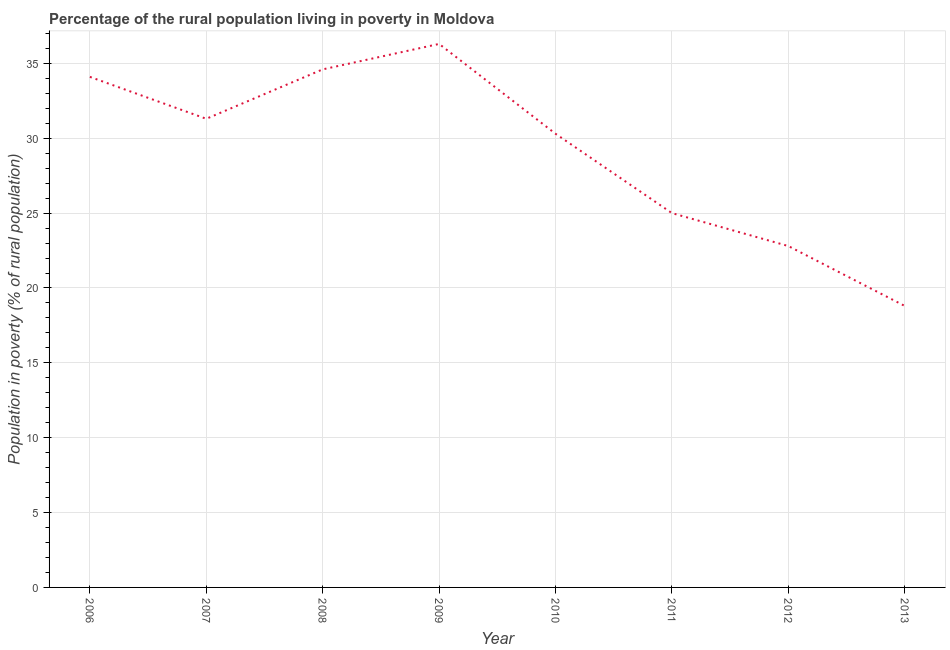Across all years, what is the maximum percentage of rural population living below poverty line?
Ensure brevity in your answer.  36.3. Across all years, what is the minimum percentage of rural population living below poverty line?
Offer a terse response. 18.8. In which year was the percentage of rural population living below poverty line minimum?
Offer a terse response. 2013. What is the sum of the percentage of rural population living below poverty line?
Your answer should be compact. 233.2. What is the difference between the percentage of rural population living below poverty line in 2008 and 2010?
Your answer should be compact. 4.3. What is the average percentage of rural population living below poverty line per year?
Make the answer very short. 29.15. What is the median percentage of rural population living below poverty line?
Make the answer very short. 30.8. What is the ratio of the percentage of rural population living below poverty line in 2012 to that in 2013?
Provide a succinct answer. 1.21. Is the difference between the percentage of rural population living below poverty line in 2010 and 2012 greater than the difference between any two years?
Give a very brief answer. No. What is the difference between the highest and the second highest percentage of rural population living below poverty line?
Your answer should be compact. 1.7. Is the sum of the percentage of rural population living below poverty line in 2006 and 2011 greater than the maximum percentage of rural population living below poverty line across all years?
Provide a short and direct response. Yes. What is the difference between the highest and the lowest percentage of rural population living below poverty line?
Your answer should be very brief. 17.5. In how many years, is the percentage of rural population living below poverty line greater than the average percentage of rural population living below poverty line taken over all years?
Ensure brevity in your answer.  5. Does the percentage of rural population living below poverty line monotonically increase over the years?
Your answer should be compact. No. What is the difference between two consecutive major ticks on the Y-axis?
Keep it short and to the point. 5. Are the values on the major ticks of Y-axis written in scientific E-notation?
Make the answer very short. No. Does the graph contain grids?
Provide a short and direct response. Yes. What is the title of the graph?
Your answer should be compact. Percentage of the rural population living in poverty in Moldova. What is the label or title of the Y-axis?
Offer a very short reply. Population in poverty (% of rural population). What is the Population in poverty (% of rural population) of 2006?
Provide a succinct answer. 34.1. What is the Population in poverty (% of rural population) in 2007?
Your answer should be very brief. 31.3. What is the Population in poverty (% of rural population) of 2008?
Your answer should be very brief. 34.6. What is the Population in poverty (% of rural population) of 2009?
Your answer should be very brief. 36.3. What is the Population in poverty (% of rural population) of 2010?
Make the answer very short. 30.3. What is the Population in poverty (% of rural population) in 2011?
Provide a short and direct response. 25. What is the Population in poverty (% of rural population) of 2012?
Offer a terse response. 22.8. What is the Population in poverty (% of rural population) in 2013?
Ensure brevity in your answer.  18.8. What is the difference between the Population in poverty (% of rural population) in 2006 and 2007?
Offer a terse response. 2.8. What is the difference between the Population in poverty (% of rural population) in 2006 and 2008?
Offer a very short reply. -0.5. What is the difference between the Population in poverty (% of rural population) in 2006 and 2010?
Ensure brevity in your answer.  3.8. What is the difference between the Population in poverty (% of rural population) in 2006 and 2012?
Give a very brief answer. 11.3. What is the difference between the Population in poverty (% of rural population) in 2007 and 2008?
Make the answer very short. -3.3. What is the difference between the Population in poverty (% of rural population) in 2007 and 2011?
Keep it short and to the point. 6.3. What is the difference between the Population in poverty (% of rural population) in 2008 and 2010?
Your answer should be very brief. 4.3. What is the difference between the Population in poverty (% of rural population) in 2008 and 2011?
Offer a terse response. 9.6. What is the difference between the Population in poverty (% of rural population) in 2009 and 2013?
Your response must be concise. 17.5. What is the difference between the Population in poverty (% of rural population) in 2010 and 2011?
Provide a succinct answer. 5.3. What is the difference between the Population in poverty (% of rural population) in 2010 and 2013?
Your response must be concise. 11.5. What is the ratio of the Population in poverty (% of rural population) in 2006 to that in 2007?
Ensure brevity in your answer.  1.09. What is the ratio of the Population in poverty (% of rural population) in 2006 to that in 2008?
Offer a terse response. 0.99. What is the ratio of the Population in poverty (% of rural population) in 2006 to that in 2009?
Give a very brief answer. 0.94. What is the ratio of the Population in poverty (% of rural population) in 2006 to that in 2011?
Offer a very short reply. 1.36. What is the ratio of the Population in poverty (% of rural population) in 2006 to that in 2012?
Your response must be concise. 1.5. What is the ratio of the Population in poverty (% of rural population) in 2006 to that in 2013?
Provide a succinct answer. 1.81. What is the ratio of the Population in poverty (% of rural population) in 2007 to that in 2008?
Your answer should be very brief. 0.91. What is the ratio of the Population in poverty (% of rural population) in 2007 to that in 2009?
Give a very brief answer. 0.86. What is the ratio of the Population in poverty (% of rural population) in 2007 to that in 2010?
Offer a terse response. 1.03. What is the ratio of the Population in poverty (% of rural population) in 2007 to that in 2011?
Provide a succinct answer. 1.25. What is the ratio of the Population in poverty (% of rural population) in 2007 to that in 2012?
Keep it short and to the point. 1.37. What is the ratio of the Population in poverty (% of rural population) in 2007 to that in 2013?
Make the answer very short. 1.67. What is the ratio of the Population in poverty (% of rural population) in 2008 to that in 2009?
Your response must be concise. 0.95. What is the ratio of the Population in poverty (% of rural population) in 2008 to that in 2010?
Give a very brief answer. 1.14. What is the ratio of the Population in poverty (% of rural population) in 2008 to that in 2011?
Provide a succinct answer. 1.38. What is the ratio of the Population in poverty (% of rural population) in 2008 to that in 2012?
Provide a succinct answer. 1.52. What is the ratio of the Population in poverty (% of rural population) in 2008 to that in 2013?
Your answer should be very brief. 1.84. What is the ratio of the Population in poverty (% of rural population) in 2009 to that in 2010?
Make the answer very short. 1.2. What is the ratio of the Population in poverty (% of rural population) in 2009 to that in 2011?
Give a very brief answer. 1.45. What is the ratio of the Population in poverty (% of rural population) in 2009 to that in 2012?
Offer a very short reply. 1.59. What is the ratio of the Population in poverty (% of rural population) in 2009 to that in 2013?
Give a very brief answer. 1.93. What is the ratio of the Population in poverty (% of rural population) in 2010 to that in 2011?
Your answer should be compact. 1.21. What is the ratio of the Population in poverty (% of rural population) in 2010 to that in 2012?
Provide a short and direct response. 1.33. What is the ratio of the Population in poverty (% of rural population) in 2010 to that in 2013?
Make the answer very short. 1.61. What is the ratio of the Population in poverty (% of rural population) in 2011 to that in 2012?
Give a very brief answer. 1.1. What is the ratio of the Population in poverty (% of rural population) in 2011 to that in 2013?
Provide a succinct answer. 1.33. What is the ratio of the Population in poverty (% of rural population) in 2012 to that in 2013?
Give a very brief answer. 1.21. 